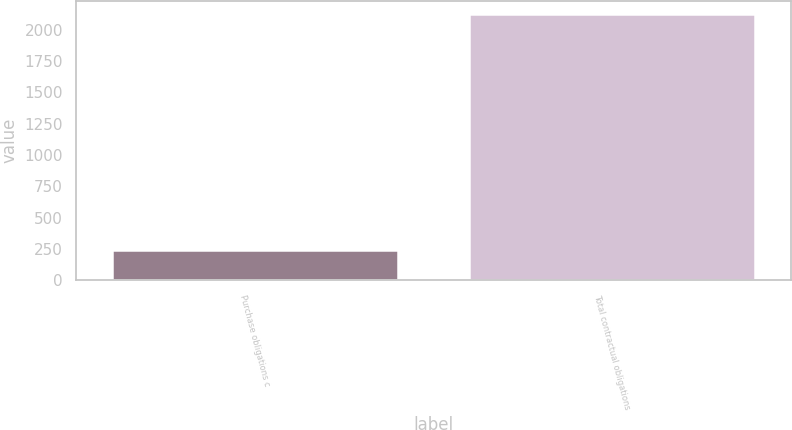Convert chart to OTSL. <chart><loc_0><loc_0><loc_500><loc_500><bar_chart><fcel>Purchase obligations c<fcel>Total contractual obligations<nl><fcel>242<fcel>2124<nl></chart> 